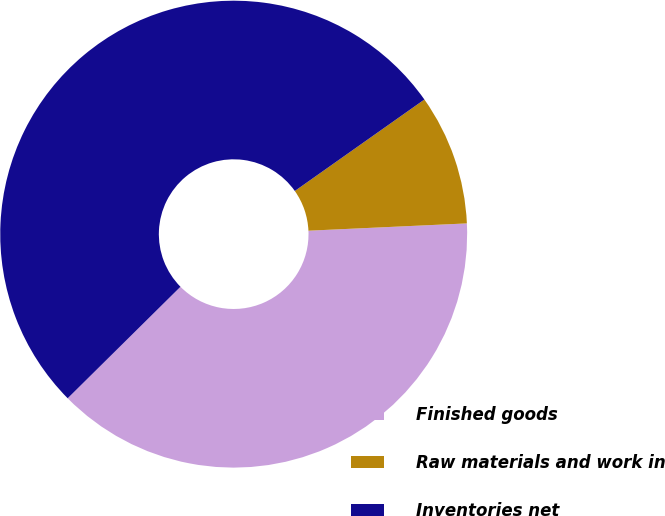Convert chart to OTSL. <chart><loc_0><loc_0><loc_500><loc_500><pie_chart><fcel>Finished goods<fcel>Raw materials and work in<fcel>Inventories net<nl><fcel>38.32%<fcel>9.05%<fcel>52.62%<nl></chart> 